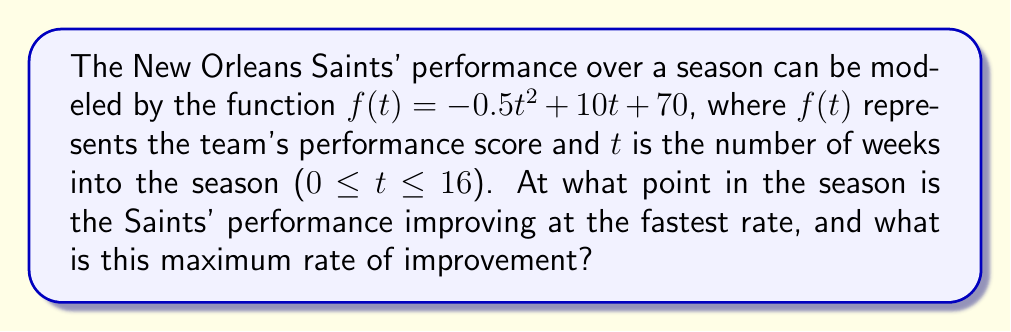Teach me how to tackle this problem. To solve this problem, we need to use derivatives to analyze the rate of change in the Saints' performance.

1) First, let's find the first derivative of $f(t)$:
   $$f'(t) = -t + 10$$

   This represents the instantaneous rate of change of the Saints' performance at any given time $t$.

2) To find when the performance is improving at the fastest rate, we need to find the maximum value of $f'(t)$. Since $f'(t)$ is a linear function, its maximum will occur at one of the endpoints of the domain.

3) The domain is 0 ≤ t ≤ 16. Let's evaluate $f'(t)$ at these endpoints:
   
   At t = 0: $f'(0) = -0 + 10 = 10$
   At t = 16: $f'(16) = -16 + 10 = -6$

4) The maximum value of $f'(t)$ occurs at t = 0, which is the beginning of the season.

5) Therefore, the Saints' performance is improving at the fastest rate at the start of the season (week 0), and the maximum rate of improvement is 10 points per week.
Answer: The Saints' performance is improving at the fastest rate at the beginning of the season (week 0), with a maximum rate of improvement of 10 points per week. 